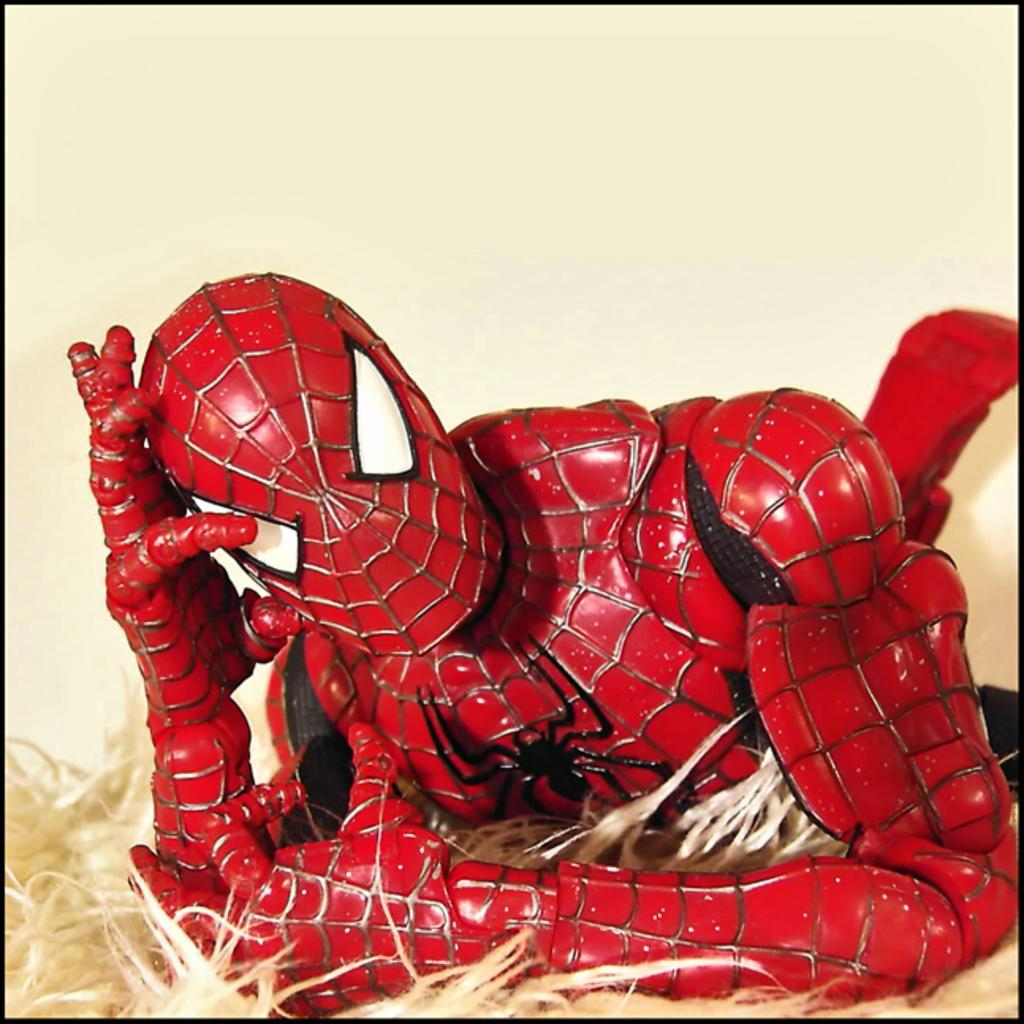What is the main subject of the image? The main subject of the image is a Spider-Man statue. What can be seen in the background of the image? There is a wall in the image. What grade of meat is being used in the image? There is no meat present in the image; it features a Spider-Man statue and a wall. 